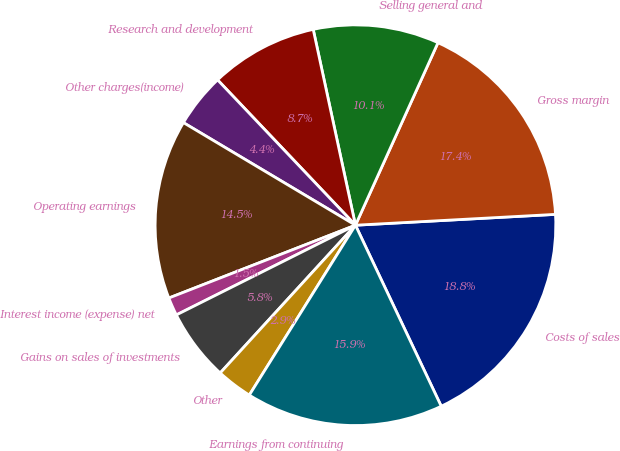<chart> <loc_0><loc_0><loc_500><loc_500><pie_chart><fcel>Costs of sales<fcel>Gross margin<fcel>Selling general and<fcel>Research and development<fcel>Other charges(income)<fcel>Operating earnings<fcel>Interest income (expense) net<fcel>Gains on sales of investments<fcel>Other<fcel>Earnings from continuing<nl><fcel>18.82%<fcel>17.38%<fcel>10.14%<fcel>8.7%<fcel>4.36%<fcel>14.48%<fcel>1.47%<fcel>5.81%<fcel>2.91%<fcel>15.93%<nl></chart> 